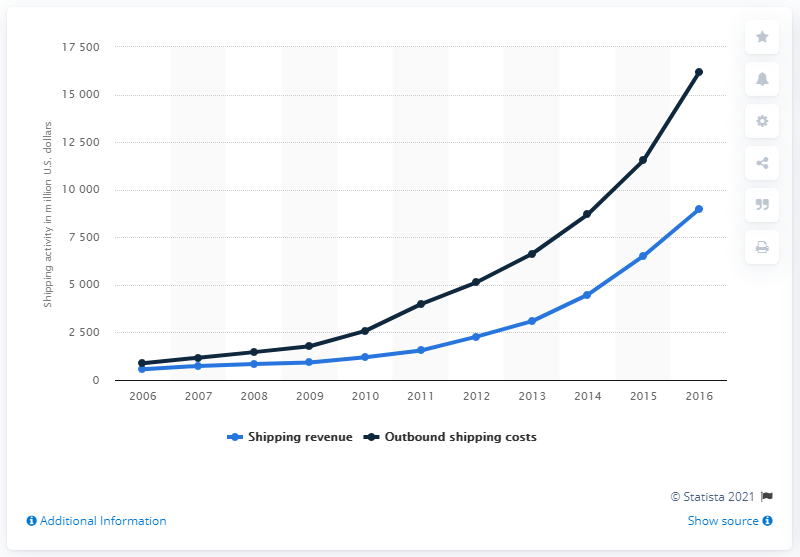Give some essential details in this illustration. Amazon's shipping revenue in 2016 was approximately $89,760. Amazon's outbound shipping cost in 2016 was approximately 16,167. 